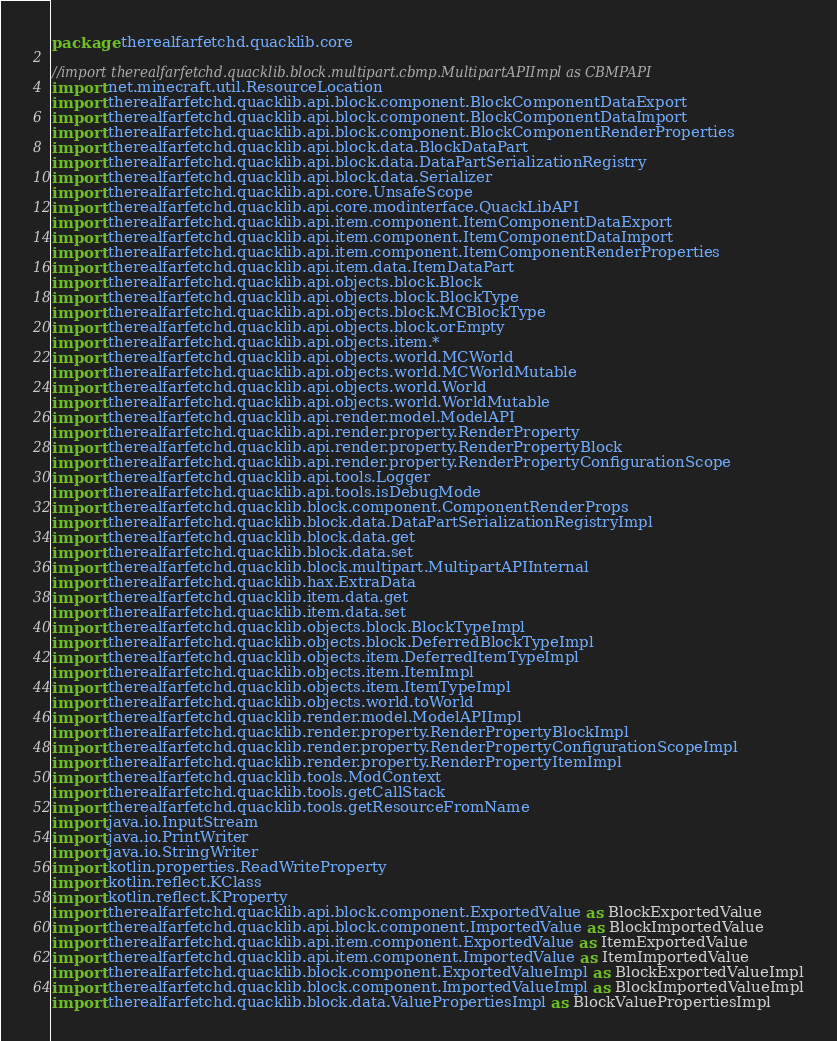Convert code to text. <code><loc_0><loc_0><loc_500><loc_500><_Kotlin_>package therealfarfetchd.quacklib.core

//import therealfarfetchd.quacklib.block.multipart.cbmp.MultipartAPIImpl as CBMPAPI
import net.minecraft.util.ResourceLocation
import therealfarfetchd.quacklib.api.block.component.BlockComponentDataExport
import therealfarfetchd.quacklib.api.block.component.BlockComponentDataImport
import therealfarfetchd.quacklib.api.block.component.BlockComponentRenderProperties
import therealfarfetchd.quacklib.api.block.data.BlockDataPart
import therealfarfetchd.quacklib.api.block.data.DataPartSerializationRegistry
import therealfarfetchd.quacklib.api.block.data.Serializer
import therealfarfetchd.quacklib.api.core.UnsafeScope
import therealfarfetchd.quacklib.api.core.modinterface.QuackLibAPI
import therealfarfetchd.quacklib.api.item.component.ItemComponentDataExport
import therealfarfetchd.quacklib.api.item.component.ItemComponentDataImport
import therealfarfetchd.quacklib.api.item.component.ItemComponentRenderProperties
import therealfarfetchd.quacklib.api.item.data.ItemDataPart
import therealfarfetchd.quacklib.api.objects.block.Block
import therealfarfetchd.quacklib.api.objects.block.BlockType
import therealfarfetchd.quacklib.api.objects.block.MCBlockType
import therealfarfetchd.quacklib.api.objects.block.orEmpty
import therealfarfetchd.quacklib.api.objects.item.*
import therealfarfetchd.quacklib.api.objects.world.MCWorld
import therealfarfetchd.quacklib.api.objects.world.MCWorldMutable
import therealfarfetchd.quacklib.api.objects.world.World
import therealfarfetchd.quacklib.api.objects.world.WorldMutable
import therealfarfetchd.quacklib.api.render.model.ModelAPI
import therealfarfetchd.quacklib.api.render.property.RenderProperty
import therealfarfetchd.quacklib.api.render.property.RenderPropertyBlock
import therealfarfetchd.quacklib.api.render.property.RenderPropertyConfigurationScope
import therealfarfetchd.quacklib.api.tools.Logger
import therealfarfetchd.quacklib.api.tools.isDebugMode
import therealfarfetchd.quacklib.block.component.ComponentRenderProps
import therealfarfetchd.quacklib.block.data.DataPartSerializationRegistryImpl
import therealfarfetchd.quacklib.block.data.get
import therealfarfetchd.quacklib.block.data.set
import therealfarfetchd.quacklib.block.multipart.MultipartAPIInternal
import therealfarfetchd.quacklib.hax.ExtraData
import therealfarfetchd.quacklib.item.data.get
import therealfarfetchd.quacklib.item.data.set
import therealfarfetchd.quacklib.objects.block.BlockTypeImpl
import therealfarfetchd.quacklib.objects.block.DeferredBlockTypeImpl
import therealfarfetchd.quacklib.objects.item.DeferredItemTypeImpl
import therealfarfetchd.quacklib.objects.item.ItemImpl
import therealfarfetchd.quacklib.objects.item.ItemTypeImpl
import therealfarfetchd.quacklib.objects.world.toWorld
import therealfarfetchd.quacklib.render.model.ModelAPIImpl
import therealfarfetchd.quacklib.render.property.RenderPropertyBlockImpl
import therealfarfetchd.quacklib.render.property.RenderPropertyConfigurationScopeImpl
import therealfarfetchd.quacklib.render.property.RenderPropertyItemImpl
import therealfarfetchd.quacklib.tools.ModContext
import therealfarfetchd.quacklib.tools.getCallStack
import therealfarfetchd.quacklib.tools.getResourceFromName
import java.io.InputStream
import java.io.PrintWriter
import java.io.StringWriter
import kotlin.properties.ReadWriteProperty
import kotlin.reflect.KClass
import kotlin.reflect.KProperty
import therealfarfetchd.quacklib.api.block.component.ExportedValue as BlockExportedValue
import therealfarfetchd.quacklib.api.block.component.ImportedValue as BlockImportedValue
import therealfarfetchd.quacklib.api.item.component.ExportedValue as ItemExportedValue
import therealfarfetchd.quacklib.api.item.component.ImportedValue as ItemImportedValue
import therealfarfetchd.quacklib.block.component.ExportedValueImpl as BlockExportedValueImpl
import therealfarfetchd.quacklib.block.component.ImportedValueImpl as BlockImportedValueImpl
import therealfarfetchd.quacklib.block.data.ValuePropertiesImpl as BlockValuePropertiesImpl</code> 